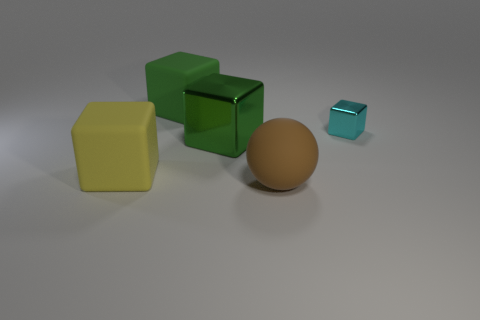Describe the colors of the cubes in the image. There are three cubes in the image: one is green with a reflective surface, another is yellow with a matte finish, and the smallest one is cyan, also with a matte appearance. 